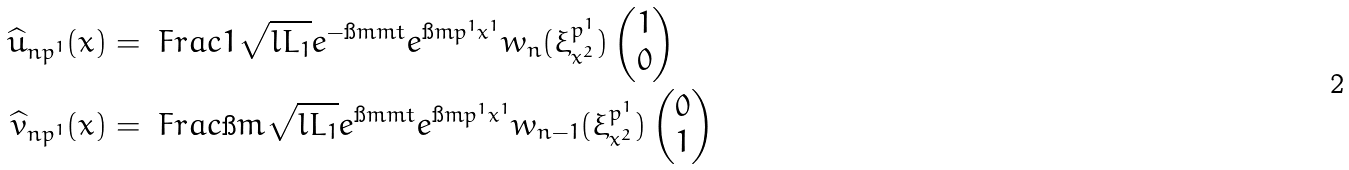<formula> <loc_0><loc_0><loc_500><loc_500>\widehat { u } _ { n p ^ { 1 } } ( x ) & = \ F r a c { 1 } { \sqrt { l L _ { 1 } } } e ^ { - \i m m t } e ^ { \i m p ^ { 1 } x ^ { 1 } } w _ { n } ( \xi _ { x ^ { 2 } } ^ { p ^ { 1 } } ) \begin{pmatrix} 1 \\ 0 \end{pmatrix} \\ \widehat { v } _ { n p ^ { 1 } } ( x ) & = \ F r a c { \i m } { \sqrt { l L _ { 1 } } } e ^ { \i m m t } e ^ { \i m p ^ { 1 } x ^ { 1 } } w _ { n - 1 } ( \xi _ { x ^ { 2 } } ^ { p ^ { 1 } } ) \begin{pmatrix} 0 \\ 1 \end{pmatrix}</formula> 